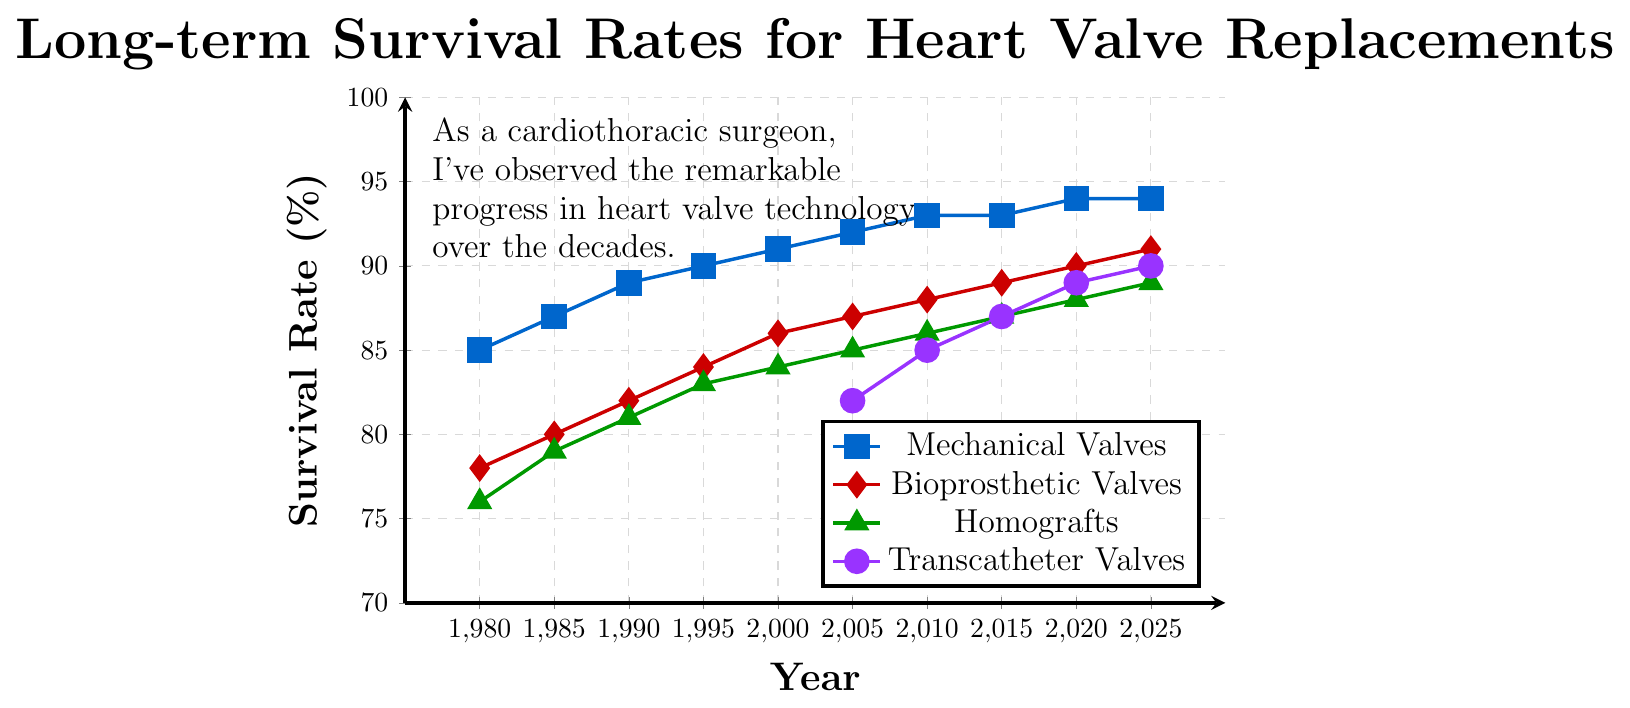What is the survival rate of mechanical valves in 2020? The plot shows a blue line representing mechanical valves. By following the blue line to the year 2020 on the x-axis, we see the corresponding y-axis value.
Answer: 94 Between 2005 and 2010, which type of valve showed the greatest improvement in survival rate? For each valve type, we need to find the difference in survival rate between 2005 and 2010. The differences are: Mechanical Valves: 93 - 92 = 1, Bioprosthetic Valves: 88 - 87 = 1, Homografts: 86 - 85 = 1, Transcatheter Valves: 85 - 82 = 3. The largest improvement is for Transcatheter Valves.
Answer: Transcatheter Valves Which valve type had the lowest survival rate in 2005? Checking the corresponding values at the year 2005 for each valve type, we find: Mechanical Valves: 92, Bioprosthetic Valves: 87, Homografts: 85, Transcatheter Valves: 82. The lowest rate is for Transcatheter Valves.
Answer: Transcatheter Valves How does the survival rate of bioprosthetic valves in 2010 compare to that of homografts in 2000? The survival rate for bioprosthetic valves in 2010 is 88 and for homografts in 2000 is 84. Comparing these, bioprosthetic valves have a higher rate.
Answer: Bioprosthetic Valves are higher What is the average survival rate for mechanical valves from 1980 to 2025? The survival rates for mechanical valves from 1980 to 2025 are: 85, 87, 89, 90, 91, 92, 93, 93, 94, 94. Summing these values gives 908. Dividing by the number of years (10) gives the average: 908/10 = 90.8.
Answer: 90.8 In which year did transcatheter valves reach a survival rate of 89%? The transcatheter valves line (purple) shows a survival rate of 89% in the year 2020.
Answer: 2020 By how much did the survival rate of bioprosthetic valves increase from 1980 to 2025? The survival rate for bioprosthetic valves in 1980 was 78, and in 2025 it was 91. The increase is 91 - 78 = 13.
Answer: 13 Which valve type shows the most consistent improvement in survival rate over the given period? Examining the trends of each valve type, mechanical valves show a fairly consistent upward trend over the entire span from 1980 to 2025.
Answer: Mechanical Valves What are the distinct colors used to represent each valve type in the plot? By looking at the legend and the colors of the lines, we see: Mechanical Valves - blue, Bioprosthetic Valves - red, Homografts - green, Transcatheter Valves - purple.
Answer: Blue, Red, Green, Purple What is the difference in survival rates between mechanical and bioprosthetic valves in 2025? The plot indicates that in 2025, the survival rate for mechanical valves is 94 and for bioprosthetic valves is 91. The difference is 94 - 91 = 3.
Answer: 3 